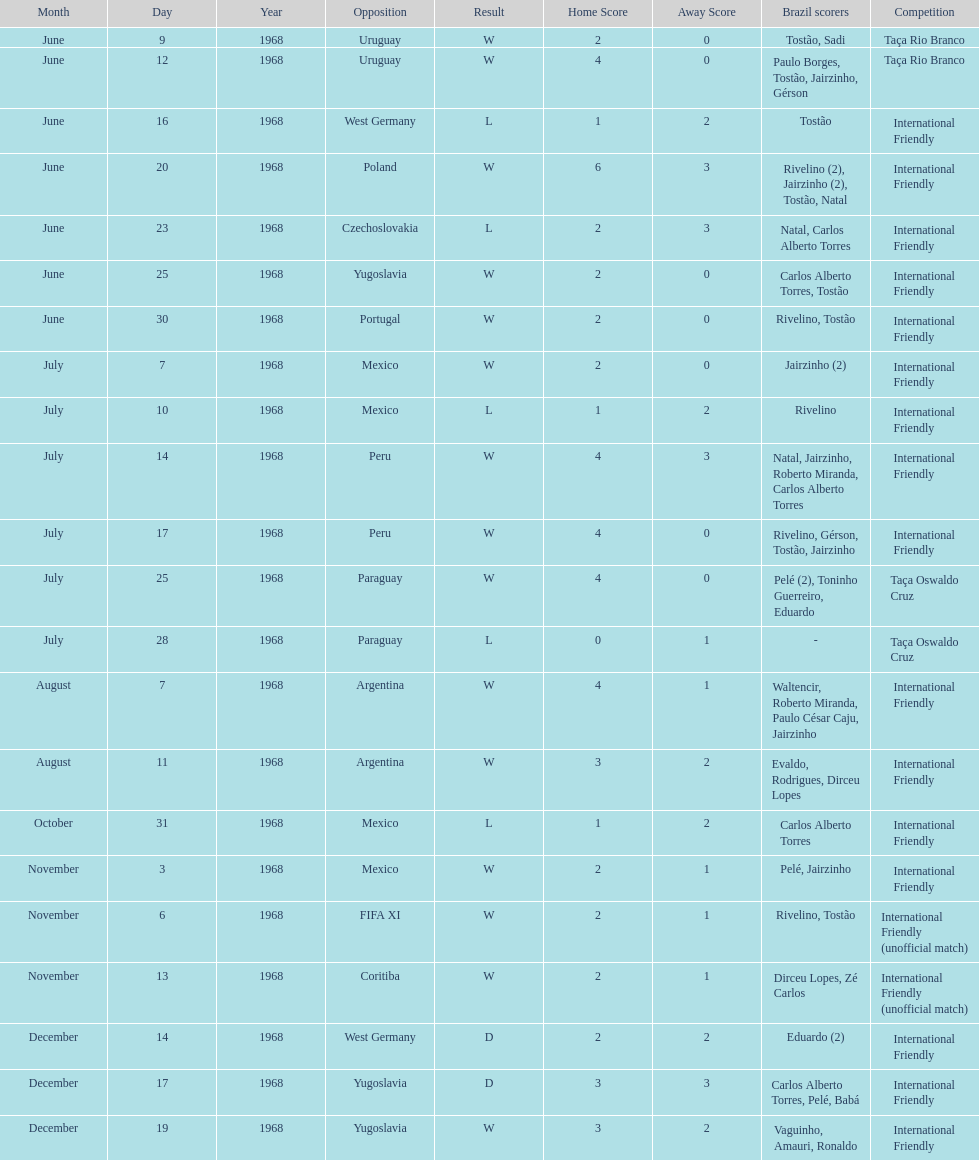Total number of wins 15. 